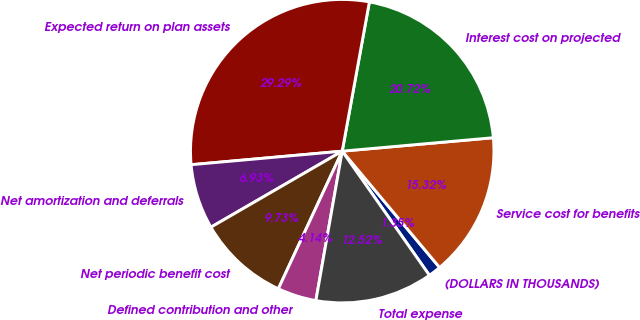<chart> <loc_0><loc_0><loc_500><loc_500><pie_chart><fcel>(DOLLARS IN THOUSANDS)<fcel>Service cost for benefits<fcel>Interest cost on projected<fcel>Expected return on plan assets<fcel>Net amortization and deferrals<fcel>Net periodic benefit cost<fcel>Defined contribution and other<fcel>Total expense<nl><fcel>1.35%<fcel>15.32%<fcel>20.72%<fcel>29.29%<fcel>6.93%<fcel>9.73%<fcel>4.14%<fcel>12.52%<nl></chart> 